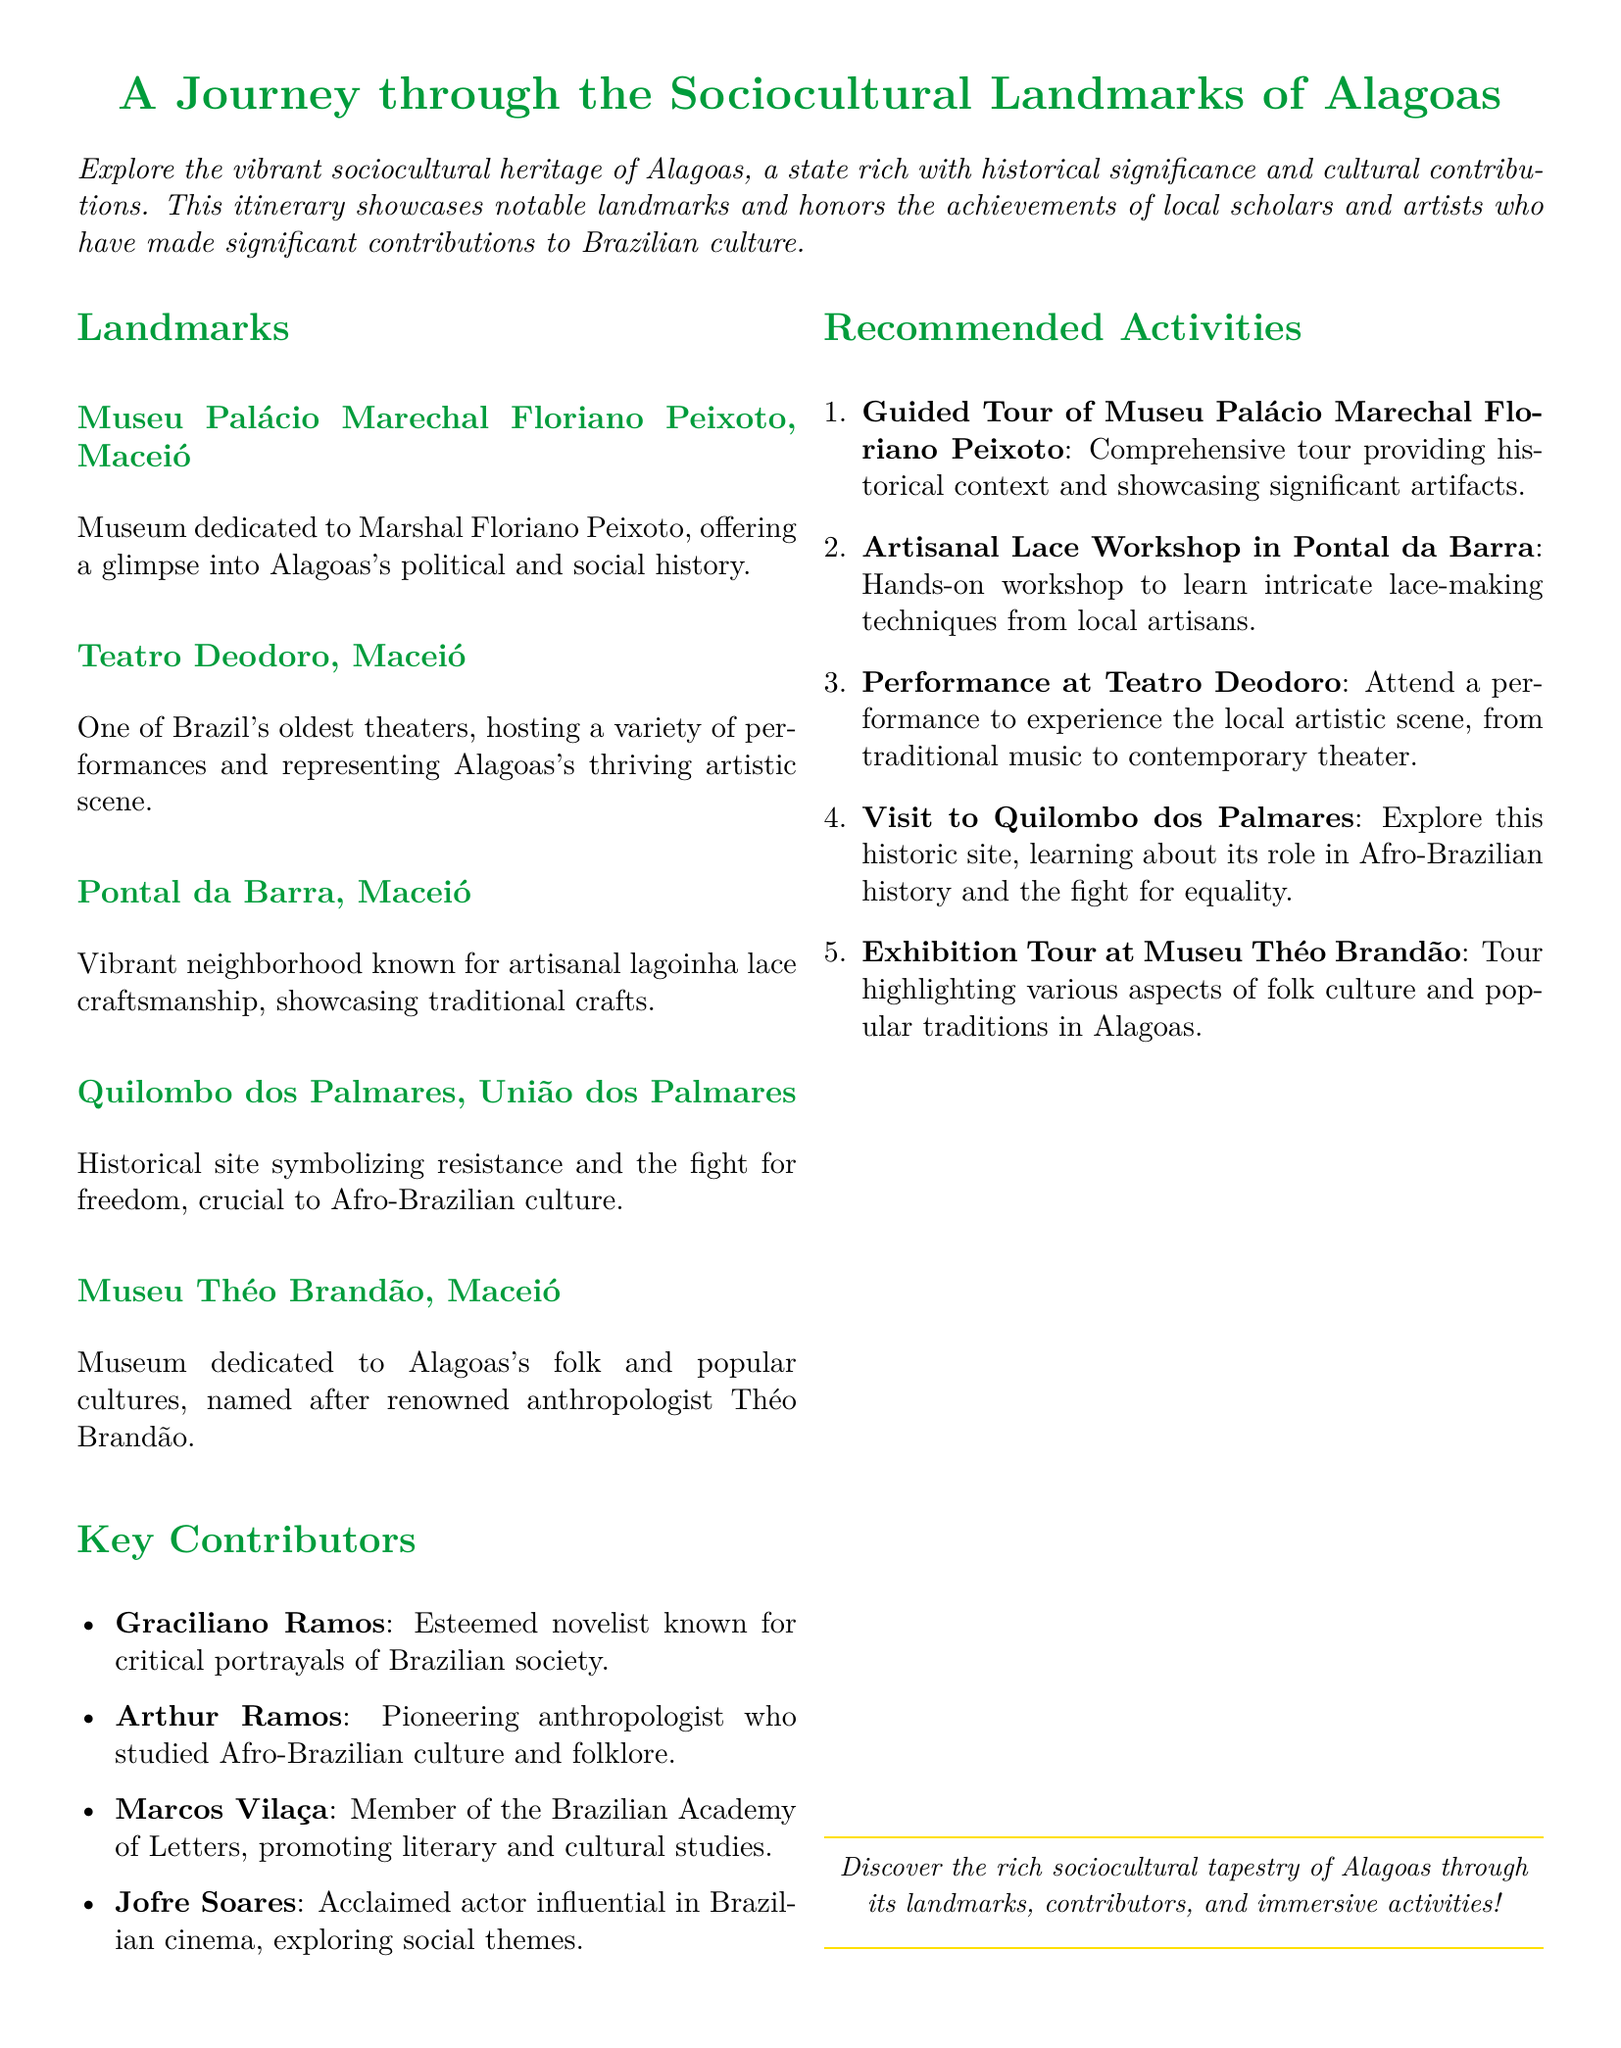What is the name of the museum dedicated to Marshal Floriano Peixoto? The museum mentioned is dedicated to Marshal Floriano Peixoto and provides insight into Alagoas's political and social history.
Answer: Museu Palácio Marechal Floriano Peixoto Which theater is one of Brazil's oldest? The document lists a theater in Maceió, highlighting its historical significance and role in the artistic scene.
Answer: Teatro Deodoro What traditional craft is associated with Pontal da Barra? Pontal da Barra is known for a specific artisanal craft that showcases the cultural heritage of Alagoas.
Answer: Lagoinha lace Who is an esteemed novelist known for critical portrayals of Brazilian society? The document mentions contributors from Alagoas, indicating their influence in literature, including a notable novelist.
Answer: Graciliano Ramos What type of workshop is recommended in Pontal da Barra? A recommended activity in this neighborhood involves learning about a specific local handicraft through an interactive experience.
Answer: Artisanal Lace Workshop What historical site symbolizes resistance in Afro-Brazilian culture? The document refers to a significant place in Afro-Brazilian history, emphasizing its importance for cultural identity and heritage.
Answer: Quilombo dos Palmares Which museum is named after a renowned anthropologist? The document states a museum that focuses on folk culture and is named after a specific influential figure in anthropology.
Answer: Museu Théo Brandão What activity involves attending performances in Maceió? The document suggests experiencing local artistic expressions through a specific venue that hosts a variety of performances.
Answer: Performance at Teatro Deodoro 